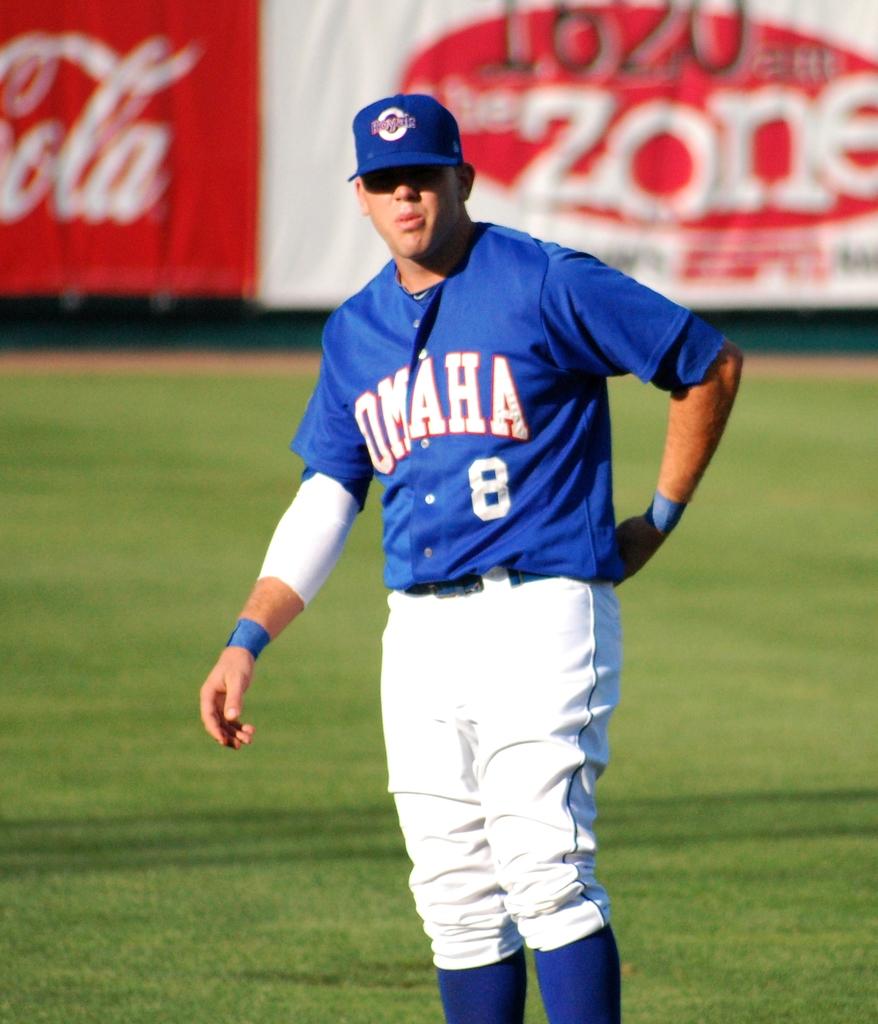What is the shirt number of this baseball player?
Make the answer very short. 8. What radio station is on the banner in the backround?
Your answer should be very brief. 1620am. 